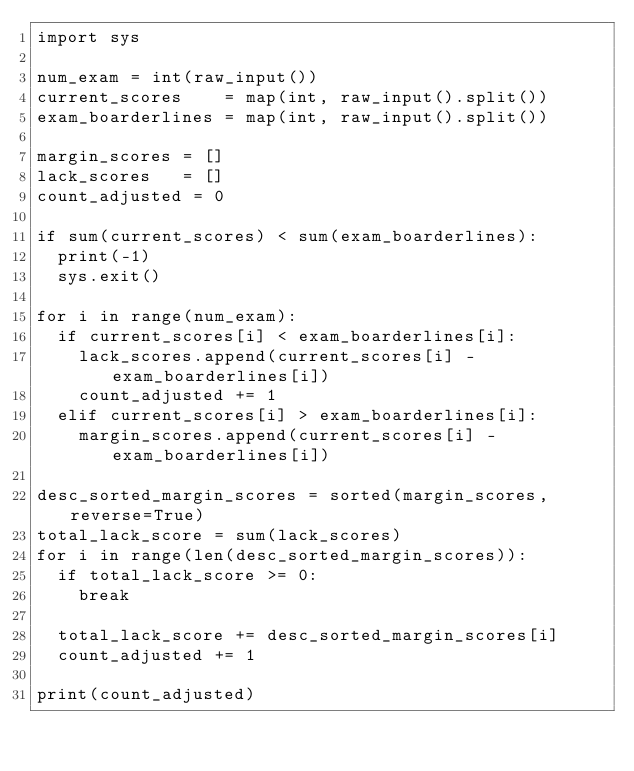Convert code to text. <code><loc_0><loc_0><loc_500><loc_500><_Python_>import sys

num_exam = int(raw_input())
current_scores    = map(int, raw_input().split())
exam_boarderlines = map(int, raw_input().split())

margin_scores = []
lack_scores   = []
count_adjusted = 0

if sum(current_scores) < sum(exam_boarderlines):
  print(-1)
  sys.exit()

for i in range(num_exam):
  if current_scores[i] < exam_boarderlines[i]:
    lack_scores.append(current_scores[i] - exam_boarderlines[i])
    count_adjusted += 1
  elif current_scores[i] > exam_boarderlines[i]:
    margin_scores.append(current_scores[i] - exam_boarderlines[i])

desc_sorted_margin_scores = sorted(margin_scores, reverse=True)
total_lack_score = sum(lack_scores)
for i in range(len(desc_sorted_margin_scores)):
  if total_lack_score >= 0:
    break

  total_lack_score += desc_sorted_margin_scores[i]
  count_adjusted += 1

print(count_adjusted)</code> 